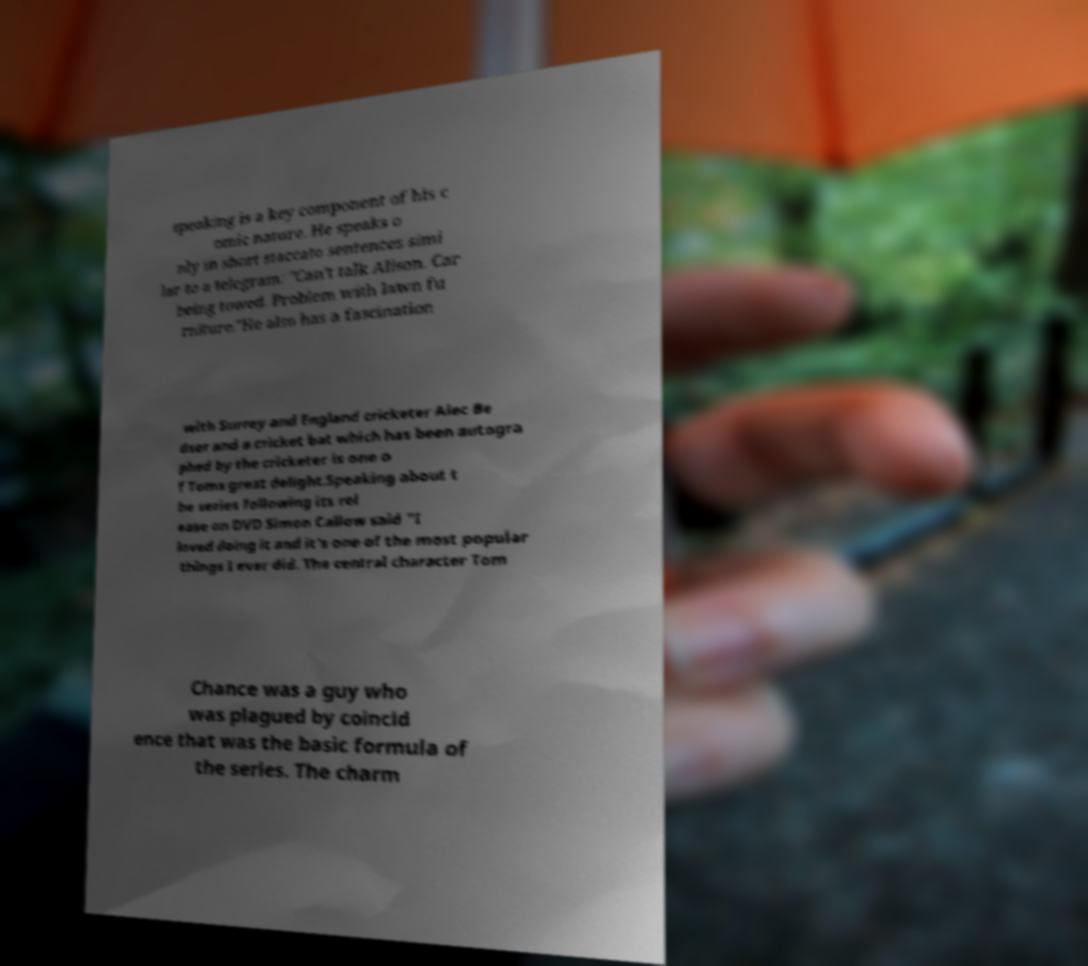For documentation purposes, I need the text within this image transcribed. Could you provide that? speaking is a key component of his c omic nature. He speaks o nly in short staccato sentences simi lar to a telegram: "Can’t talk Alison. Car being towed. Problem with lawn fu rniture."He also has a fascination with Surrey and England cricketer Alec Be dser and a cricket bat which has been autogra phed by the cricketer is one o f Toms great delight.Speaking about t he series following its rel ease on DVD Simon Callow said "I loved doing it and it's one of the most popular things I ever did. The central character Tom Chance was a guy who was plagued by coincid ence that was the basic formula of the series. The charm 